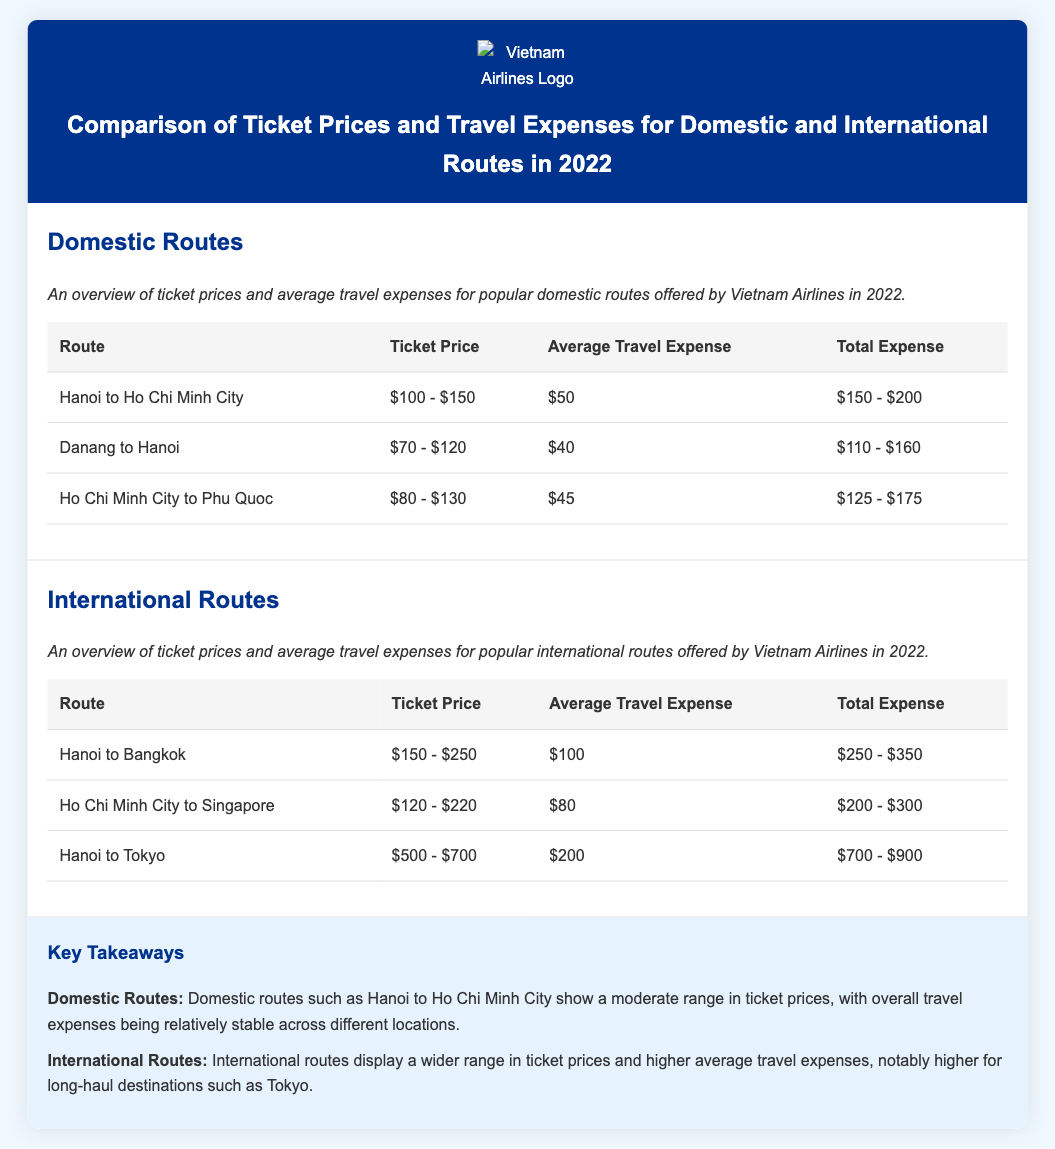What is the ticket price range for Hanoi to Ho Chi Minh City? The ticket price range for this route is explicitly stated in the document as $100 - $150.
Answer: $100 - $150 What is the average travel expense for the route from Ho Chi Minh City to Phu Quoc? The average travel expense for this route is mentioned in the document as $45.
Answer: $45 Which international route has the highest total expense? By examining the total expenses for each international route, Hanoi to Tokyo has the highest total expense, which is $700 - $900.
Answer: $700 - $900 What is the average travel expense for international routes? The average travel expenses for international routes are given as $100, $80, and $200, which indicates variability but average around the higher end.
Answer: Varies, higher average How much is the total expense for Danang to Hanoi? The total expense range for this route is stated in the document as $110 - $160.
Answer: $110 - $160 What is noted about travel expenses for long-haul international routes? The document highlights that long-haul international routes such as to Tokyo exhibit a wider range in ticket prices and higher average travel expenses.
Answer: Higher average expenses What is the average travel expense for the route from Hanoi to Bangkok? The average travel expense for this route is reported in the document as $100.
Answer: $100 Which domestic route has the lowest average travel expense? By comparing the averages listed, the domestic route from Ho Chi Minh City to Phu Quoc has the lowest average travel expense of $45.
Answer: $45 